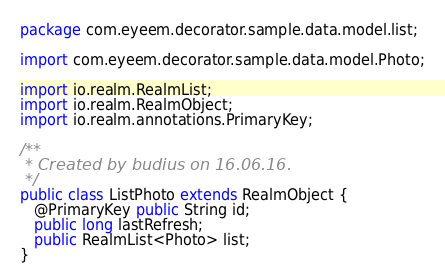<code> <loc_0><loc_0><loc_500><loc_500><_Java_>package com.eyeem.decorator.sample.data.model.list;

import com.eyeem.decorator.sample.data.model.Photo;

import io.realm.RealmList;
import io.realm.RealmObject;
import io.realm.annotations.PrimaryKey;

/**
 * Created by budius on 16.06.16.
 */
public class ListPhoto extends RealmObject {
   @PrimaryKey public String id;
   public long lastRefresh;
   public RealmList<Photo> list;
}</code> 